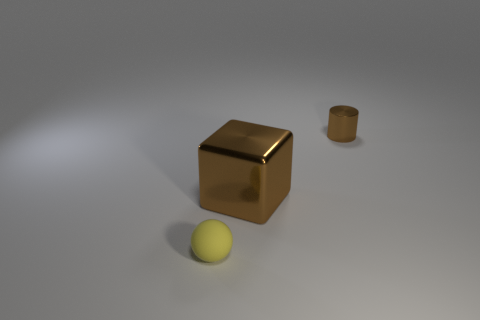How many metal things are yellow things or big brown objects?
Offer a terse response. 1. What is the material of the cylinder that is the same size as the matte sphere?
Offer a terse response. Metal. What number of other things are the same material as the large brown thing?
Ensure brevity in your answer.  1. Is the number of shiny cubes that are right of the block less than the number of tiny brown matte spheres?
Your answer should be compact. No. Is the big metal thing the same shape as the yellow rubber thing?
Keep it short and to the point. No. How big is the brown thing behind the brown thing that is to the left of the object that is behind the brown block?
Offer a very short reply. Small. Is there any other thing that has the same size as the metal cylinder?
Provide a short and direct response. Yes. There is a brown thing that is in front of the tiny object that is on the right side of the yellow sphere; what size is it?
Provide a succinct answer. Large. What color is the small sphere?
Your answer should be very brief. Yellow. There is a shiny object left of the tiny brown metallic object; how many tiny yellow rubber objects are behind it?
Your answer should be compact. 0. 